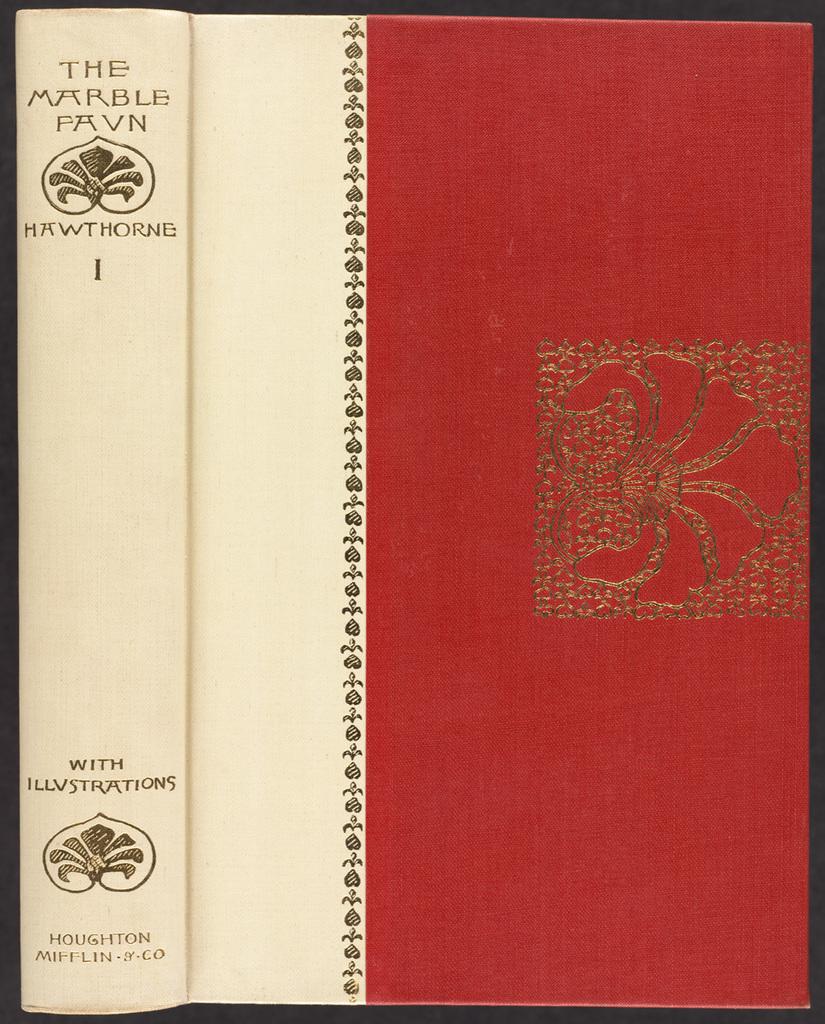What is the title of the book?
Make the answer very short. The marble favn. Who is the author?
Offer a terse response. Hawthorne. 